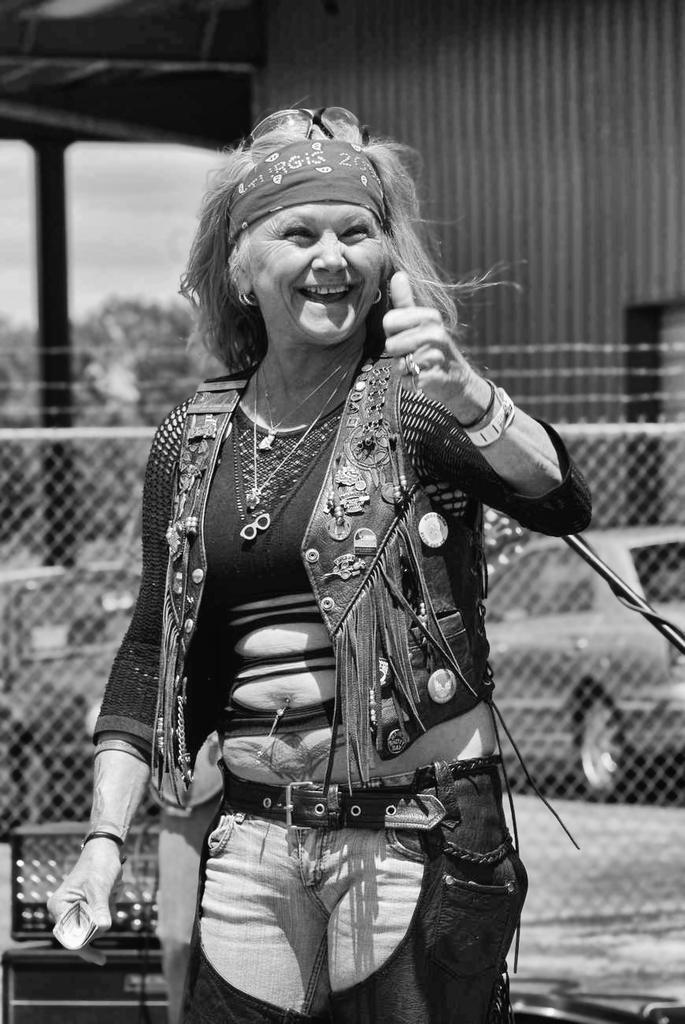How would you summarize this image in a sentence or two? In this image I can see the black and white picture of a woman wearing black color dress is standing and in the background I can see the metal fence, a car on the ground, few trees, the sky and the shed. 